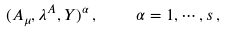Convert formula to latex. <formula><loc_0><loc_0><loc_500><loc_500>( A _ { \mu } , \lambda ^ { A } , Y ) ^ { \alpha } \, , \quad \alpha = 1 , \cdots , s \, ,</formula> 